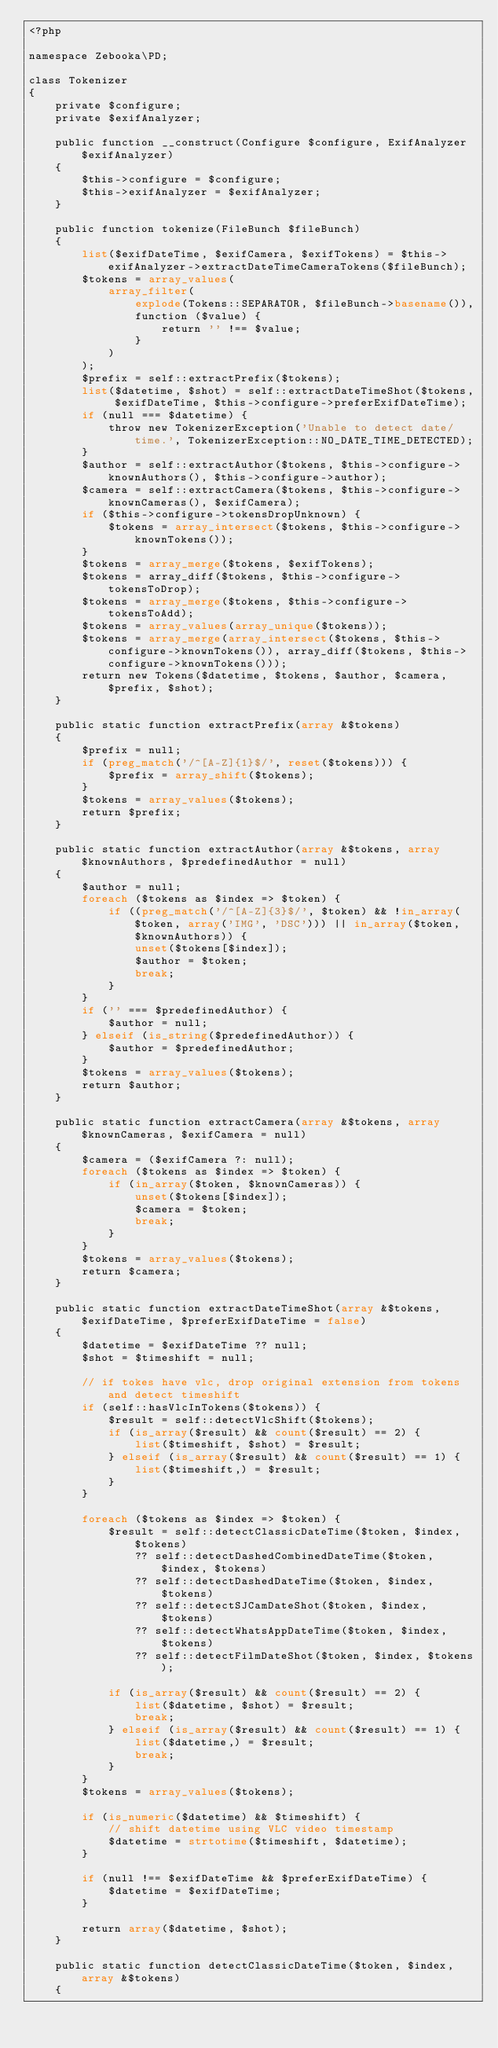Convert code to text. <code><loc_0><loc_0><loc_500><loc_500><_PHP_><?php

namespace Zebooka\PD;

class Tokenizer
{
    private $configure;
    private $exifAnalyzer;

    public function __construct(Configure $configure, ExifAnalyzer $exifAnalyzer)
    {
        $this->configure = $configure;
        $this->exifAnalyzer = $exifAnalyzer;
    }

    public function tokenize(FileBunch $fileBunch)
    {
        list($exifDateTime, $exifCamera, $exifTokens) = $this->exifAnalyzer->extractDateTimeCameraTokens($fileBunch);
        $tokens = array_values(
            array_filter(
                explode(Tokens::SEPARATOR, $fileBunch->basename()),
                function ($value) {
                    return '' !== $value;
                }
            )
        );
        $prefix = self::extractPrefix($tokens);
        list($datetime, $shot) = self::extractDateTimeShot($tokens, $exifDateTime, $this->configure->preferExifDateTime);
        if (null === $datetime) {
            throw new TokenizerException('Unable to detect date/time.', TokenizerException::NO_DATE_TIME_DETECTED);
        }
        $author = self::extractAuthor($tokens, $this->configure->knownAuthors(), $this->configure->author);
        $camera = self::extractCamera($tokens, $this->configure->knownCameras(), $exifCamera);
        if ($this->configure->tokensDropUnknown) {
            $tokens = array_intersect($tokens, $this->configure->knownTokens());
        }
        $tokens = array_merge($tokens, $exifTokens);
        $tokens = array_diff($tokens, $this->configure->tokensToDrop);
        $tokens = array_merge($tokens, $this->configure->tokensToAdd);
        $tokens = array_values(array_unique($tokens));
        $tokens = array_merge(array_intersect($tokens, $this->configure->knownTokens()), array_diff($tokens, $this->configure->knownTokens()));
        return new Tokens($datetime, $tokens, $author, $camera, $prefix, $shot);
    }

    public static function extractPrefix(array &$tokens)
    {
        $prefix = null;
        if (preg_match('/^[A-Z]{1}$/', reset($tokens))) {
            $prefix = array_shift($tokens);
        }
        $tokens = array_values($tokens);
        return $prefix;
    }

    public static function extractAuthor(array &$tokens, array $knownAuthors, $predefinedAuthor = null)
    {
        $author = null;
        foreach ($tokens as $index => $token) {
            if ((preg_match('/^[A-Z]{3}$/', $token) && !in_array($token, array('IMG', 'DSC'))) || in_array($token, $knownAuthors)) {
                unset($tokens[$index]);
                $author = $token;
                break;
            }
        }
        if ('' === $predefinedAuthor) {
            $author = null;
        } elseif (is_string($predefinedAuthor)) {
            $author = $predefinedAuthor;
        }
        $tokens = array_values($tokens);
        return $author;
    }

    public static function extractCamera(array &$tokens, array $knownCameras, $exifCamera = null)
    {
        $camera = ($exifCamera ?: null);
        foreach ($tokens as $index => $token) {
            if (in_array($token, $knownCameras)) {
                unset($tokens[$index]);
                $camera = $token;
                break;
            }
        }
        $tokens = array_values($tokens);
        return $camera;
    }

    public static function extractDateTimeShot(array &$tokens, $exifDateTime, $preferExifDateTime = false)
    {
        $datetime = $exifDateTime ?? null;
        $shot = $timeshift = null;

        // if tokes have vlc, drop original extension from tokens and detect timeshift
        if (self::hasVlcInTokens($tokens)) {
            $result = self::detectVlcShift($tokens);
            if (is_array($result) && count($result) == 2) {
                list($timeshift, $shot) = $result;
            } elseif (is_array($result) && count($result) == 1) {
                list($timeshift,) = $result;
            }
        }

        foreach ($tokens as $index => $token) {
            $result = self::detectClassicDateTime($token, $index, $tokens)
                ?? self::detectDashedCombinedDateTime($token, $index, $tokens)
                ?? self::detectDashedDateTime($token, $index, $tokens)
                ?? self::detectSJCamDateShot($token, $index, $tokens)
                ?? self::detectWhatsAppDateTime($token, $index, $tokens)
                ?? self::detectFilmDateShot($token, $index, $tokens);

            if (is_array($result) && count($result) == 2) {
                list($datetime, $shot) = $result;
                break;
            } elseif (is_array($result) && count($result) == 1) {
                list($datetime,) = $result;
                break;
            }
        }
        $tokens = array_values($tokens);

        if (is_numeric($datetime) && $timeshift) {
            // shift datetime using VLC video timestamp
            $datetime = strtotime($timeshift, $datetime);
        }

        if (null !== $exifDateTime && $preferExifDateTime) {
            $datetime = $exifDateTime;
        }

        return array($datetime, $shot);
    }

    public static function detectClassicDateTime($token, $index, array &$tokens)
    {</code> 